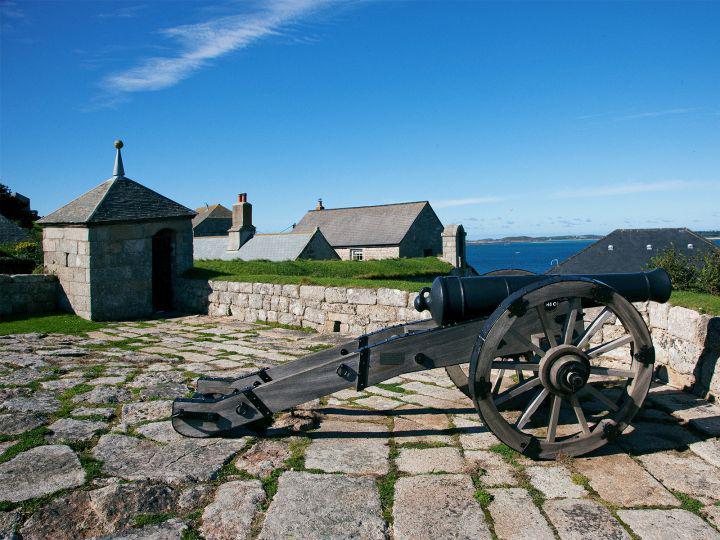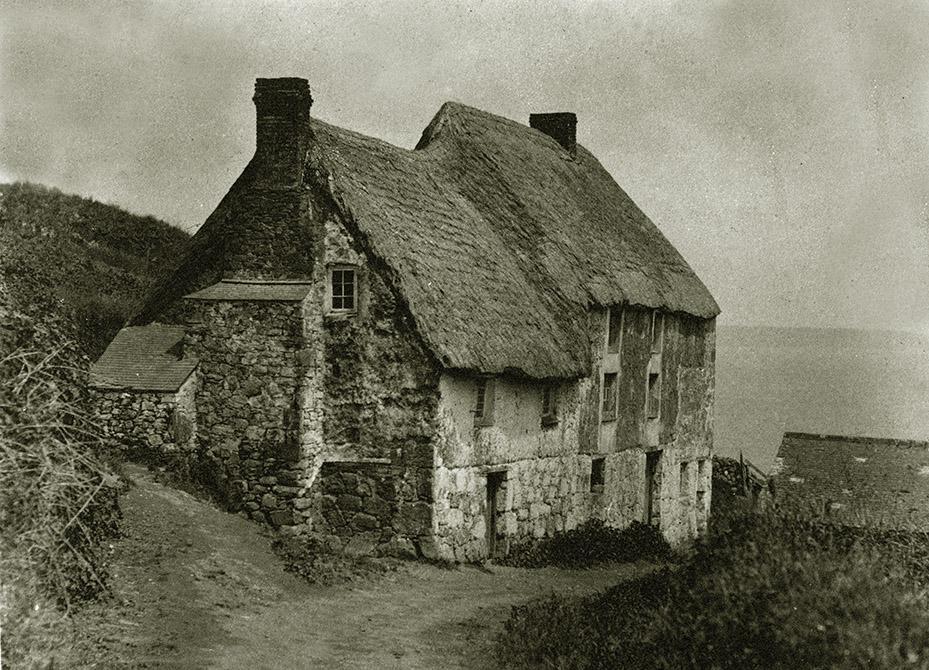The first image is the image on the left, the second image is the image on the right. Considering the images on both sides, is "One image shows buildings with smooth, flat, straight roofs, and the the other image shows rustic-looking stone buildings with roofs that are textured and uneven-looking." valid? Answer yes or no. Yes. 